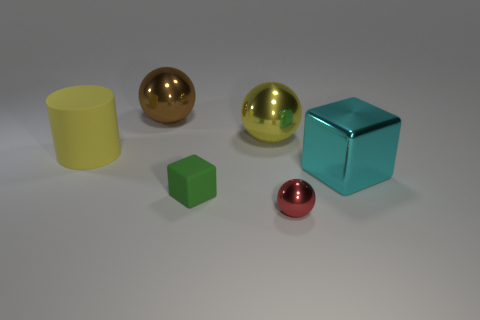There is a large thing that is in front of the matte object that is to the left of the green thing; what shape is it?
Your answer should be compact. Cube. How many other things are the same shape as the cyan metallic object?
Offer a very short reply. 1. Do the big metallic ball in front of the brown ball and the big matte cylinder have the same color?
Provide a succinct answer. Yes. Is there a thing of the same color as the cylinder?
Provide a succinct answer. Yes. There is a shiny ball on the right side of the yellow metal object; how big is it?
Keep it short and to the point. Small. What number of big spheres have the same material as the green object?
Your answer should be very brief. 0. There is a object that is the same color as the cylinder; what is its shape?
Your response must be concise. Sphere. There is a matte thing in front of the big cyan block; is its shape the same as the cyan metallic thing?
Keep it short and to the point. Yes. What is the color of the big thing that is the same material as the tiny green cube?
Your response must be concise. Yellow. Are there any yellow metal objects on the left side of the red sphere that is right of the metallic object that is behind the large yellow metal object?
Your answer should be very brief. Yes. 